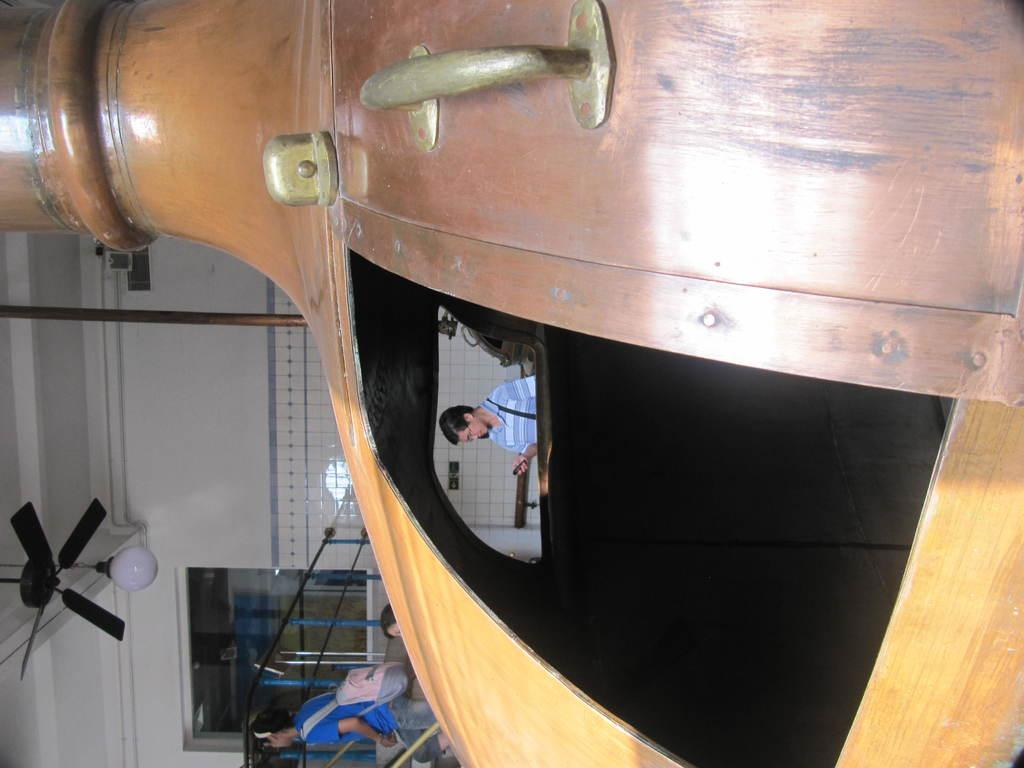What type of structure is present in the image? There is a building in the image. What features can be seen at the top of the building? There is a fan and a light at the top of the building. Who or what can be seen in the image? There are people in the image. What other objects are present in the image? There is a pole and a wall in the image. Can you describe the object in the image? There is an object in the image, but its specific details are not mentioned in the facts. What type of camp can be seen in the image? There is no camp present in the image; it features a building with a fan, light, people, a pole, and a wall. How many achievers are visible in the image? The term "achiever" is not mentioned in the facts, and there is no indication of any achievements or awards in the image. 